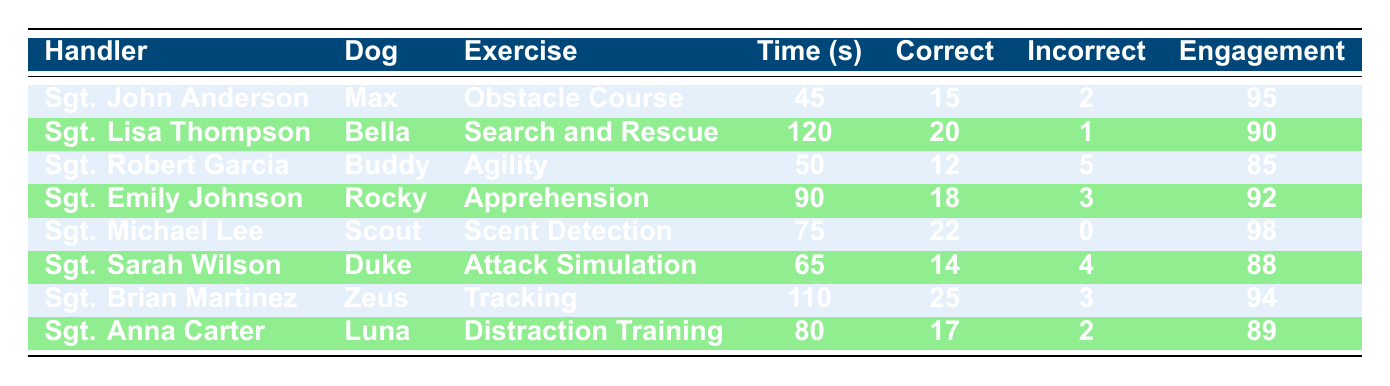What is the completion time for Sgt. John Anderson's exercise? The table shows that Sgt. John Anderson's completion time for the Obstacle Course is 45 seconds.
Answer: 45 seconds How many correct commands did Sgt. Lisa Thompson give during her exercise? According to the table, Sgt. Lisa Thompson gave 20 correct commands during the Search and Rescue exercise.
Answer: 20 Which handler had the highest engagement score? The table indicates that Sgt. Michael Lee had the highest engagement score of 98 during the Scent Detection exercise.
Answer: 98 What is the average completion time for Sgt. Emily Johnson and Sgt. Sarah Wilson? Sgt. Emily Johnson completed her exercise in 90 seconds, and Sgt. Sarah Wilson completed hers in 65 seconds. The average is (90 + 65) / 2 = 77.5 seconds.
Answer: 77.5 seconds Did Sgt. Brian Martinez have more correct commands or incorrect commands during his training? The table shows that Sgt. Brian Martinez had 25 correct commands and 3 incorrect commands, which means he had more correct commands.
Answer: Yes How many total incorrect commands were recorded for all handlers? By summing the incorrect commands for each handler: 2 (Anderson) + 1 (Thompson) + 5 (Garcia) + 3 (Johnson) + 0 (Lee) + 4 (Wilson) + 3 (Martinez) + 2 (Carter) = 20 total incorrect commands.
Answer: 20 Which exercise had the longest completion time? The table indicates that the Search and Rescue exercise, conducted by Sgt. Lisa Thompson, had the longest completion time of 120 seconds.
Answer: 120 seconds Which handler performed the best based on the number of correct commands? Sgt. Brian Martinez achieved the highest number of correct commands with 25 during the Tracking exercise, according to the table.
Answer: Sgt. Brian Martinez What is the difference in engagement score between Sgt. John Anderson and Sgt. Robert Garcia? Sgt. John Anderson had an engagement score of 95, while Sgt. Robert Garcia had a score of 85. The difference is 95 - 85 = 10 points.
Answer: 10 points 